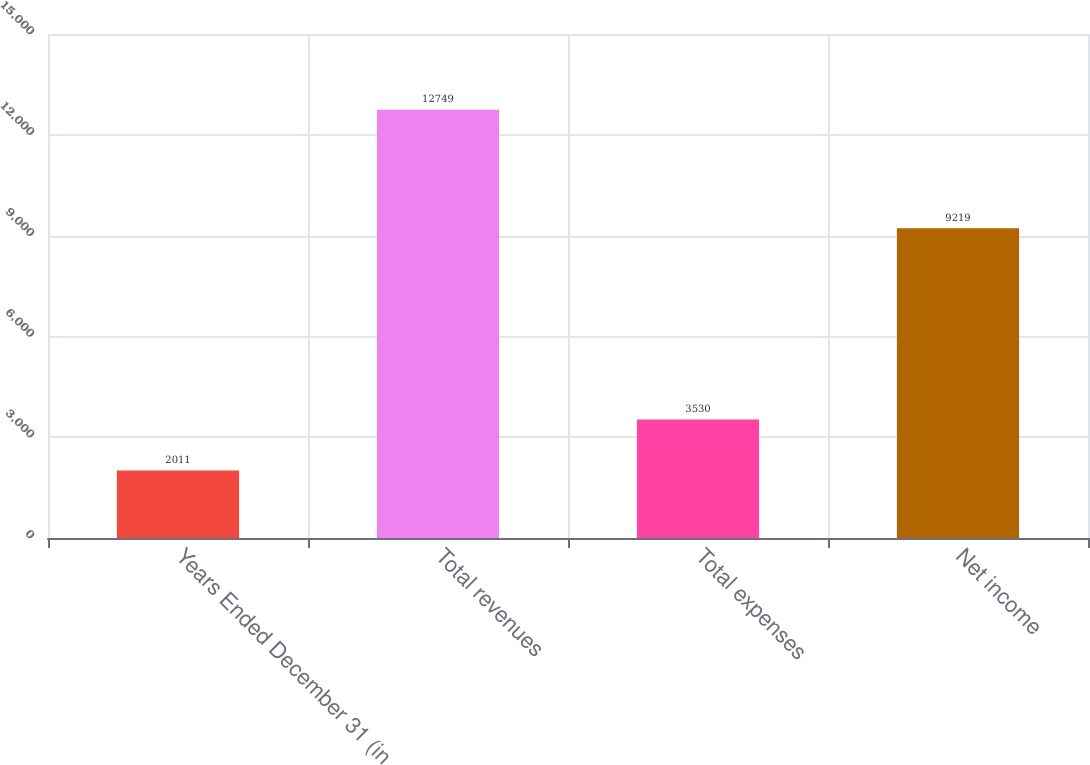Convert chart to OTSL. <chart><loc_0><loc_0><loc_500><loc_500><bar_chart><fcel>Years Ended December 31 (in<fcel>Total revenues<fcel>Total expenses<fcel>Net income<nl><fcel>2011<fcel>12749<fcel>3530<fcel>9219<nl></chart> 